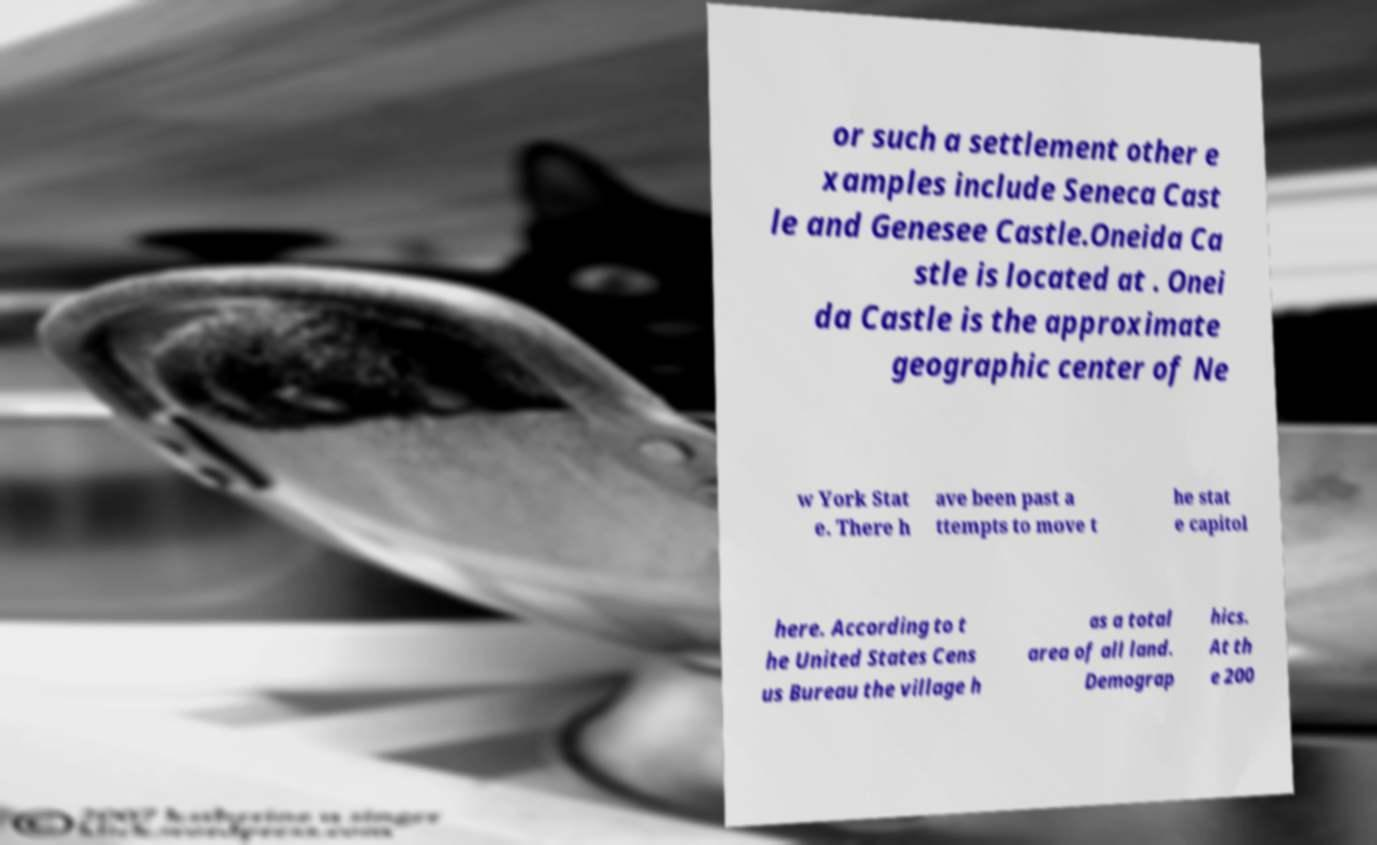What messages or text are displayed in this image? I need them in a readable, typed format. or such a settlement other e xamples include Seneca Cast le and Genesee Castle.Oneida Ca stle is located at . Onei da Castle is the approximate geographic center of Ne w York Stat e. There h ave been past a ttempts to move t he stat e capitol here. According to t he United States Cens us Bureau the village h as a total area of all land. Demograp hics. At th e 200 